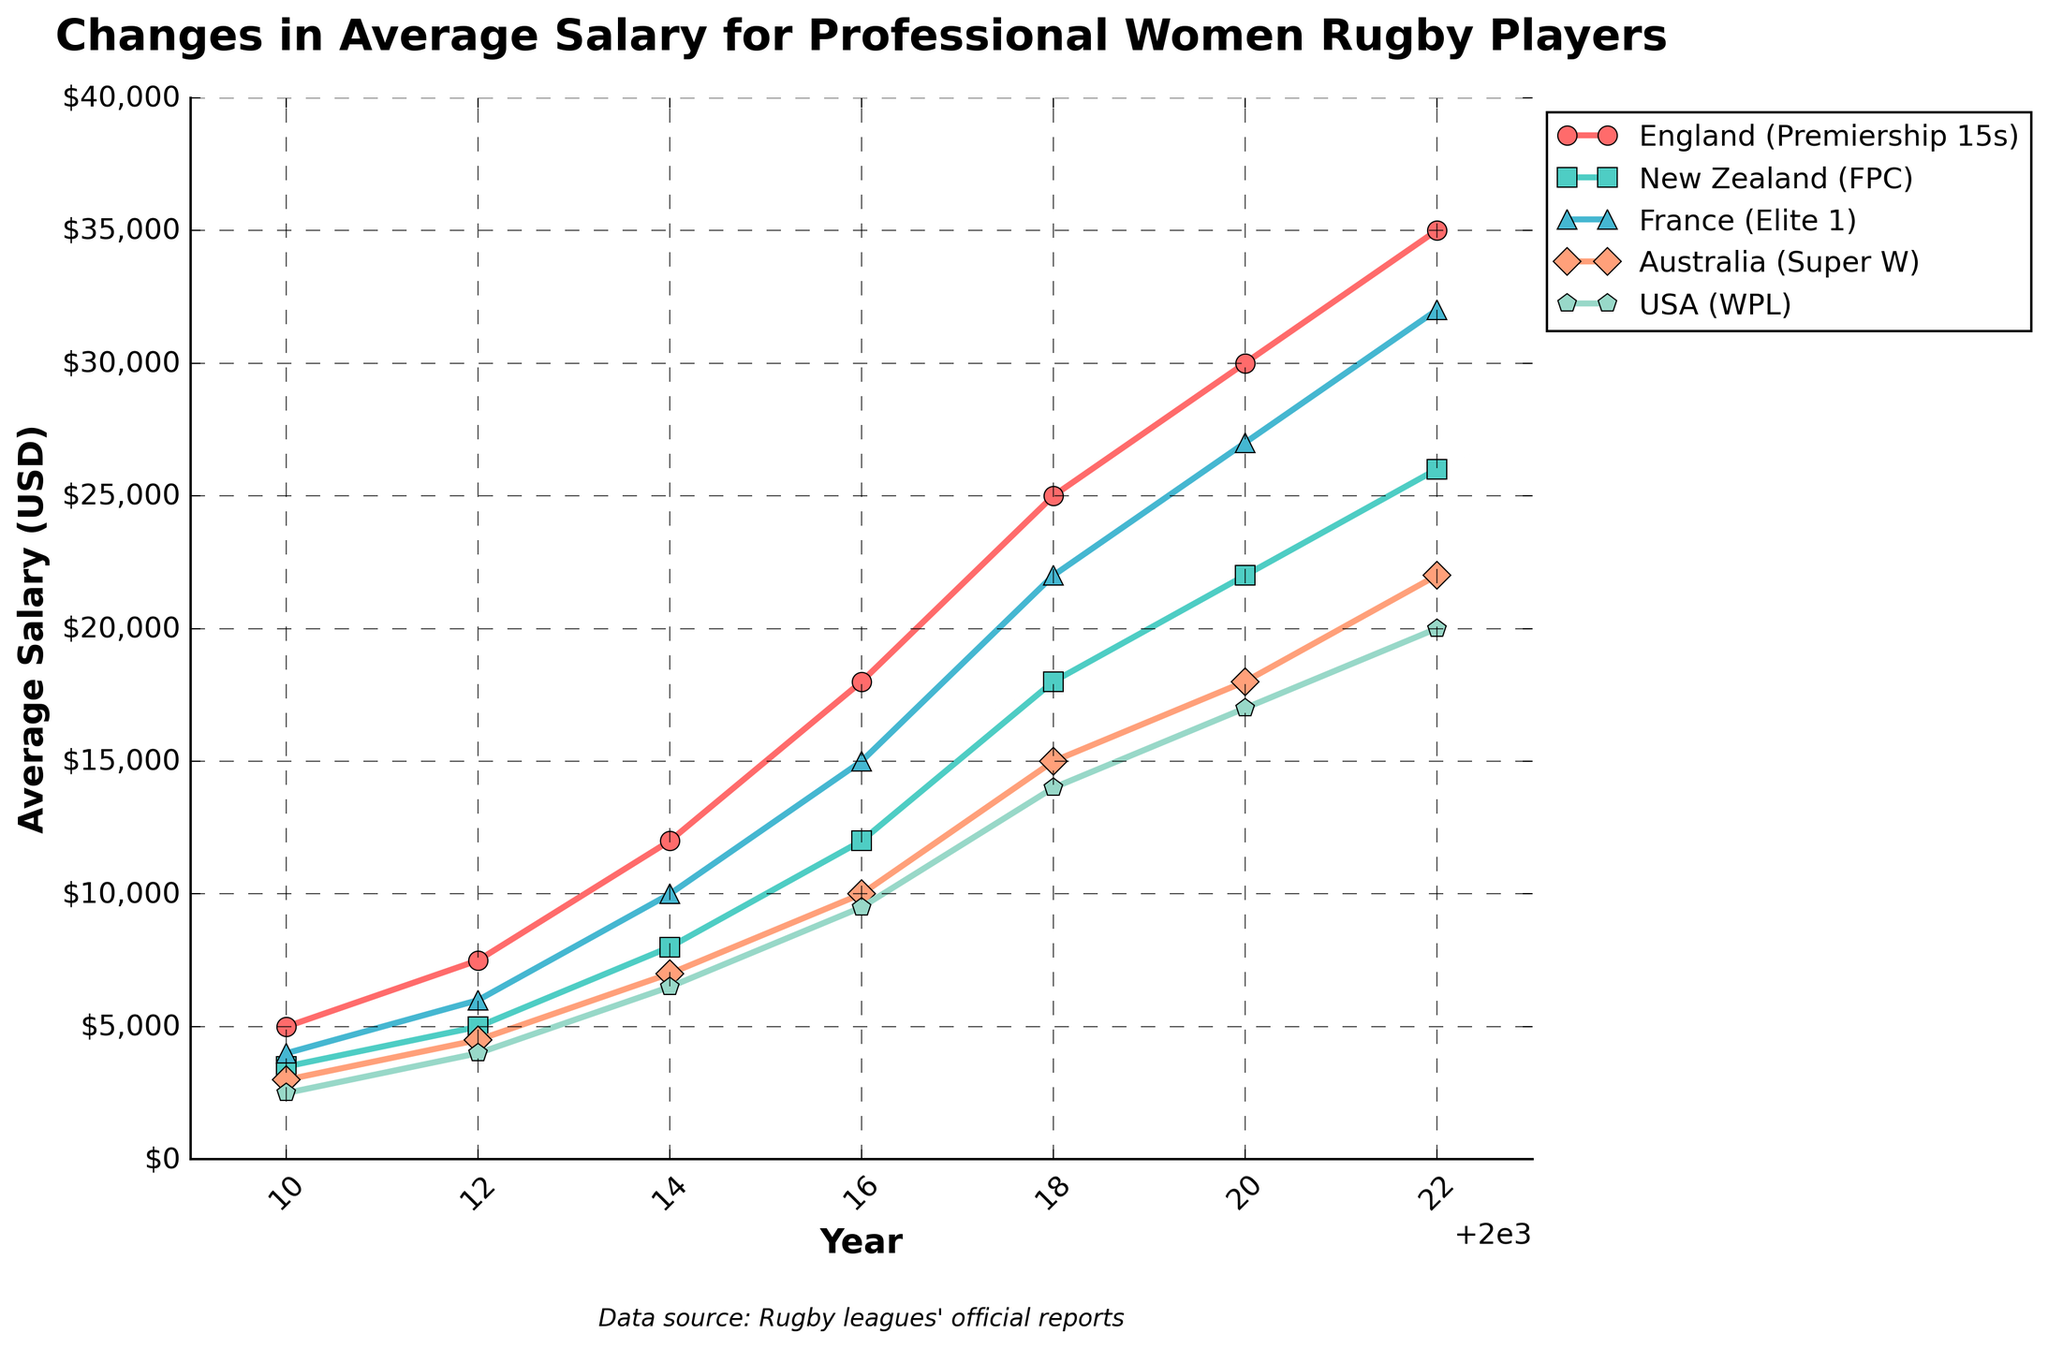What was the average salary for professional women rugby players in England (Premiership 15s) in 2014? Identify the line representing England (red with circle markers). In 2014, the line's height shows 12,000 USD.
Answer: 12,000 Which league showed the highest average salary in 2022? Examine the endpoints of all lines in the year 2022. The red line (England Premiership 15s) is highest.
Answer: England (Premiership 15s) Compare the average salary growth between New Zealand (FPC) and Australia (Super W) from 2010 to 2016. Which league experienced higher growth? Calculate the differences between 2016 and 2010 for both. For New Zealand, it's 12,000 - 3,500 = 8,500 USD, and for Australia, it's 10,000 - 3,000 = 7,000 USD.
Answer: New Zealand (FPC) What is the combined average salary for France (Elite 1) and USA (WPL) in 2020? Add the values for both leagues in 2020: 27,000 USD (France) + 17,000 USD (USA) = 44,000 USD
Answer: 44,000 By how much did the average salary for professional women rugby players in Australia (Super W) increase from 2010 to 2022? Subtract the 2010 value from the 2022 value for Australia: 22,000 USD - 3,000 USD = 19,000 USD
Answer: 19,000 Which league had the smallest average salary in 2010? Identify the lowest point on the leftmost side of the graph for the year 2010. The pink line (USA WPL) is the lowest at 2,500 USD.
Answer: USA (WPL) What was the average increase per year in the salary for professional women rugby players in France (Elite 1) between 2014 and 2018? Calculate the increase: 22,000 USD - 10,000 USD = 12,000 USD. Then, divide by the number of years: 12,000 USD / 4 years = 3,000 USD per year.
Answer: 3,000 USD per year 